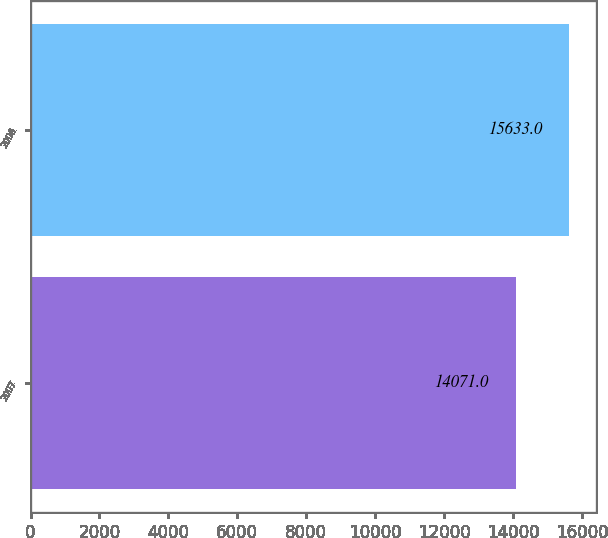Convert chart. <chart><loc_0><loc_0><loc_500><loc_500><bar_chart><fcel>2007<fcel>2006<nl><fcel>14071<fcel>15633<nl></chart> 